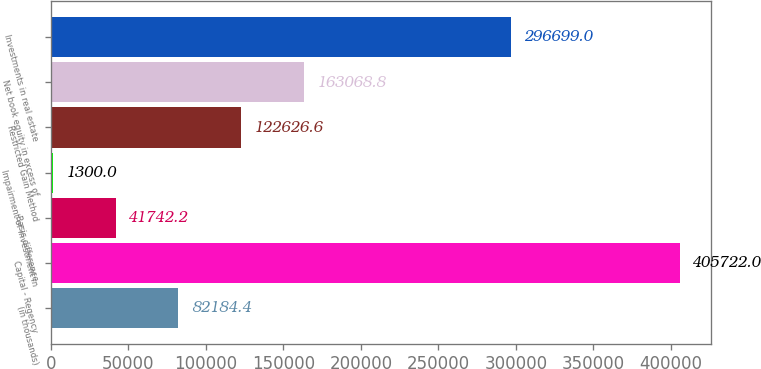Convert chart. <chart><loc_0><loc_0><loc_500><loc_500><bar_chart><fcel>(in thousands)<fcel>Capital - Regency<fcel>Basis difference<fcel>Impairment of investment in<fcel>Restricted Gain Method<fcel>Net book equity in excess of<fcel>Investments in real estate<nl><fcel>82184.4<fcel>405722<fcel>41742.2<fcel>1300<fcel>122627<fcel>163069<fcel>296699<nl></chart> 